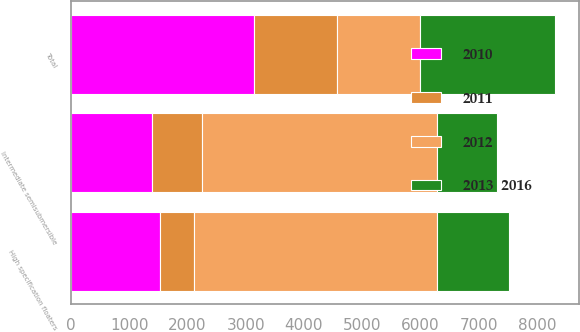Convert chart. <chart><loc_0><loc_0><loc_500><loc_500><stacked_bar_chart><ecel><fcel>High specification floaters<fcel>Intermediate semisubmersible<fcel>Total<nl><fcel>2012<fcel>4177<fcel>4030<fcel>1430<nl><fcel>2010<fcel>1536<fcel>1393<fcel>3139<nl><fcel>2013  2016<fcel>1245<fcel>1026<fcel>2310<nl><fcel>2011<fcel>570<fcel>860<fcel>1430<nl></chart> 